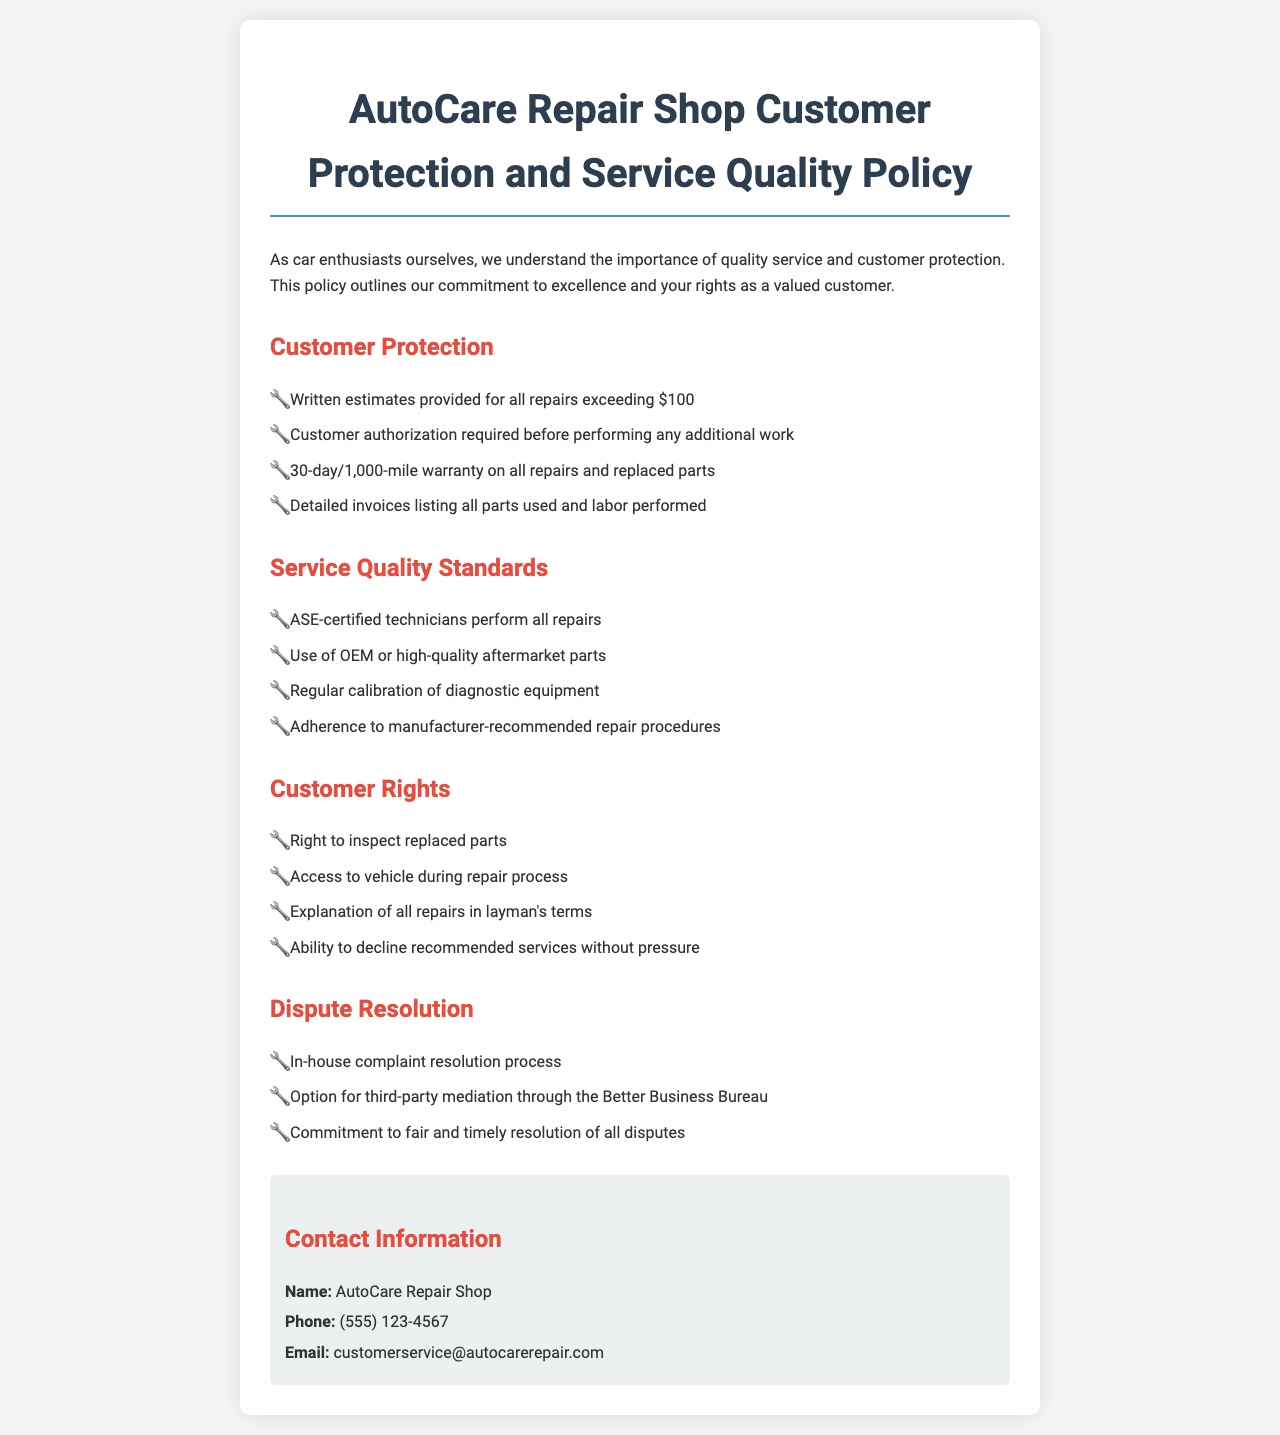What is the warranty period on repairs? The warranty period on repairs and replaced parts is specified to be 30 days or 1,000 miles.
Answer: 30-day/1,000-mile Who must authorize additional work? The document states that customer authorization is required before performing any additional work.
Answer: Customer What kind of parts do technicians use for repairs? The policy mentions that technicians use OEM or high-quality aftermarket parts for repairs.
Answer: OEM or high-quality aftermarket parts How many types of complaint resolution are listed? The document lists two types of complaint resolution: in-house resolution and third-party mediation through the Better Business Bureau.
Answer: Two What certification do the technicians hold? It is stated in the policy that all repairs are performed by ASE-certified technicians.
Answer: ASE-certified What is the contact email for customer service? The email address provided for customer service inquiries is customerservice@autocarerepair.com.
Answer: customerservice@autocarerepair.com What right do customers have regarding replaced parts? Customers have the right to inspect replaced parts.
Answer: Inspect replaced parts How is every repair explained to customers? The document specifies that all repairs are explained in layman's terms to customers.
Answer: Layman's terms What is required for repairs exceeding $100? The policy mandates that written estimates must be provided for all repairs that exceed $100.
Answer: Written estimates 